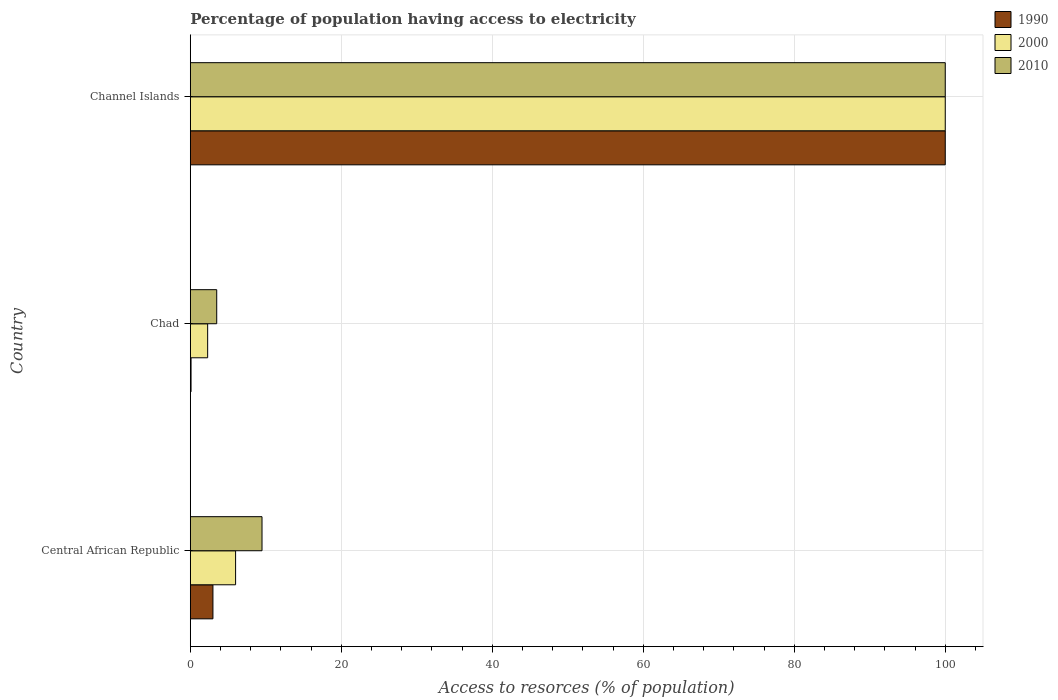How many different coloured bars are there?
Your response must be concise. 3. How many groups of bars are there?
Give a very brief answer. 3. Are the number of bars per tick equal to the number of legend labels?
Make the answer very short. Yes. Are the number of bars on each tick of the Y-axis equal?
Provide a succinct answer. Yes. How many bars are there on the 2nd tick from the bottom?
Provide a succinct answer. 3. What is the label of the 2nd group of bars from the top?
Give a very brief answer. Chad. In how many cases, is the number of bars for a given country not equal to the number of legend labels?
Your answer should be compact. 0. In which country was the percentage of population having access to electricity in 2010 maximum?
Your answer should be compact. Channel Islands. In which country was the percentage of population having access to electricity in 2010 minimum?
Make the answer very short. Chad. What is the total percentage of population having access to electricity in 2010 in the graph?
Your response must be concise. 113. What is the average percentage of population having access to electricity in 2010 per country?
Provide a succinct answer. 37.67. What is the difference between the percentage of population having access to electricity in 2010 and percentage of population having access to electricity in 2000 in Channel Islands?
Your answer should be compact. 0. What is the ratio of the percentage of population having access to electricity in 2010 in Central African Republic to that in Chad?
Offer a terse response. 2.71. Is the percentage of population having access to electricity in 1990 in Chad less than that in Channel Islands?
Make the answer very short. Yes. Is the difference between the percentage of population having access to electricity in 2010 in Chad and Channel Islands greater than the difference between the percentage of population having access to electricity in 2000 in Chad and Channel Islands?
Keep it short and to the point. Yes. What is the difference between the highest and the second highest percentage of population having access to electricity in 1990?
Give a very brief answer. 97. What is the difference between the highest and the lowest percentage of population having access to electricity in 2000?
Provide a succinct answer. 97.7. In how many countries, is the percentage of population having access to electricity in 2000 greater than the average percentage of population having access to electricity in 2000 taken over all countries?
Offer a terse response. 1. What does the 1st bar from the bottom in Channel Islands represents?
Offer a terse response. 1990. Is it the case that in every country, the sum of the percentage of population having access to electricity in 2010 and percentage of population having access to electricity in 1990 is greater than the percentage of population having access to electricity in 2000?
Make the answer very short. Yes. How many bars are there?
Make the answer very short. 9. What is the difference between two consecutive major ticks on the X-axis?
Offer a terse response. 20. Are the values on the major ticks of X-axis written in scientific E-notation?
Make the answer very short. No. Does the graph contain grids?
Provide a succinct answer. Yes. Where does the legend appear in the graph?
Keep it short and to the point. Top right. How many legend labels are there?
Offer a very short reply. 3. How are the legend labels stacked?
Your answer should be very brief. Vertical. What is the title of the graph?
Provide a short and direct response. Percentage of population having access to electricity. What is the label or title of the X-axis?
Offer a terse response. Access to resorces (% of population). What is the Access to resorces (% of population) of 2000 in Central African Republic?
Offer a terse response. 6. What is the Access to resorces (% of population) in 2000 in Chad?
Your response must be concise. 2.3. What is the Access to resorces (% of population) of 1990 in Channel Islands?
Offer a terse response. 100. Across all countries, what is the minimum Access to resorces (% of population) of 2010?
Your answer should be very brief. 3.5. What is the total Access to resorces (% of population) in 1990 in the graph?
Your answer should be very brief. 103.1. What is the total Access to resorces (% of population) of 2000 in the graph?
Provide a short and direct response. 108.3. What is the total Access to resorces (% of population) of 2010 in the graph?
Offer a terse response. 113. What is the difference between the Access to resorces (% of population) in 1990 in Central African Republic and that in Channel Islands?
Your answer should be very brief. -97. What is the difference between the Access to resorces (% of population) in 2000 in Central African Republic and that in Channel Islands?
Offer a terse response. -94. What is the difference between the Access to resorces (% of population) in 2010 in Central African Republic and that in Channel Islands?
Your answer should be compact. -90.5. What is the difference between the Access to resorces (% of population) of 1990 in Chad and that in Channel Islands?
Provide a short and direct response. -99.9. What is the difference between the Access to resorces (% of population) in 2000 in Chad and that in Channel Islands?
Offer a terse response. -97.7. What is the difference between the Access to resorces (% of population) of 2010 in Chad and that in Channel Islands?
Offer a terse response. -96.5. What is the difference between the Access to resorces (% of population) in 1990 in Central African Republic and the Access to resorces (% of population) in 2010 in Chad?
Your answer should be very brief. -0.5. What is the difference between the Access to resorces (% of population) of 1990 in Central African Republic and the Access to resorces (% of population) of 2000 in Channel Islands?
Your response must be concise. -97. What is the difference between the Access to resorces (% of population) of 1990 in Central African Republic and the Access to resorces (% of population) of 2010 in Channel Islands?
Provide a succinct answer. -97. What is the difference between the Access to resorces (% of population) in 2000 in Central African Republic and the Access to resorces (% of population) in 2010 in Channel Islands?
Give a very brief answer. -94. What is the difference between the Access to resorces (% of population) of 1990 in Chad and the Access to resorces (% of population) of 2000 in Channel Islands?
Provide a short and direct response. -99.9. What is the difference between the Access to resorces (% of population) of 1990 in Chad and the Access to resorces (% of population) of 2010 in Channel Islands?
Keep it short and to the point. -99.9. What is the difference between the Access to resorces (% of population) in 2000 in Chad and the Access to resorces (% of population) in 2010 in Channel Islands?
Keep it short and to the point. -97.7. What is the average Access to resorces (% of population) of 1990 per country?
Your answer should be compact. 34.37. What is the average Access to resorces (% of population) of 2000 per country?
Provide a short and direct response. 36.1. What is the average Access to resorces (% of population) of 2010 per country?
Provide a short and direct response. 37.67. What is the difference between the Access to resorces (% of population) of 1990 and Access to resorces (% of population) of 2000 in Central African Republic?
Ensure brevity in your answer.  -3. What is the difference between the Access to resorces (% of population) of 2000 and Access to resorces (% of population) of 2010 in Central African Republic?
Your answer should be compact. -3.5. What is the difference between the Access to resorces (% of population) in 1990 and Access to resorces (% of population) in 2000 in Chad?
Your response must be concise. -2.2. What is the difference between the Access to resorces (% of population) in 1990 and Access to resorces (% of population) in 2010 in Chad?
Offer a terse response. -3.4. What is the difference between the Access to resorces (% of population) of 1990 and Access to resorces (% of population) of 2000 in Channel Islands?
Offer a terse response. 0. What is the difference between the Access to resorces (% of population) in 1990 and Access to resorces (% of population) in 2010 in Channel Islands?
Provide a short and direct response. 0. What is the difference between the Access to resorces (% of population) in 2000 and Access to resorces (% of population) in 2010 in Channel Islands?
Provide a short and direct response. 0. What is the ratio of the Access to resorces (% of population) of 1990 in Central African Republic to that in Chad?
Provide a short and direct response. 30. What is the ratio of the Access to resorces (% of population) of 2000 in Central African Republic to that in Chad?
Your answer should be very brief. 2.61. What is the ratio of the Access to resorces (% of population) in 2010 in Central African Republic to that in Chad?
Your answer should be compact. 2.71. What is the ratio of the Access to resorces (% of population) of 2010 in Central African Republic to that in Channel Islands?
Offer a very short reply. 0.1. What is the ratio of the Access to resorces (% of population) of 1990 in Chad to that in Channel Islands?
Provide a short and direct response. 0. What is the ratio of the Access to resorces (% of population) of 2000 in Chad to that in Channel Islands?
Make the answer very short. 0.02. What is the ratio of the Access to resorces (% of population) in 2010 in Chad to that in Channel Islands?
Your answer should be very brief. 0.04. What is the difference between the highest and the second highest Access to resorces (% of population) of 1990?
Provide a succinct answer. 97. What is the difference between the highest and the second highest Access to resorces (% of population) of 2000?
Your answer should be compact. 94. What is the difference between the highest and the second highest Access to resorces (% of population) of 2010?
Your response must be concise. 90.5. What is the difference between the highest and the lowest Access to resorces (% of population) of 1990?
Make the answer very short. 99.9. What is the difference between the highest and the lowest Access to resorces (% of population) of 2000?
Your answer should be very brief. 97.7. What is the difference between the highest and the lowest Access to resorces (% of population) of 2010?
Your answer should be compact. 96.5. 